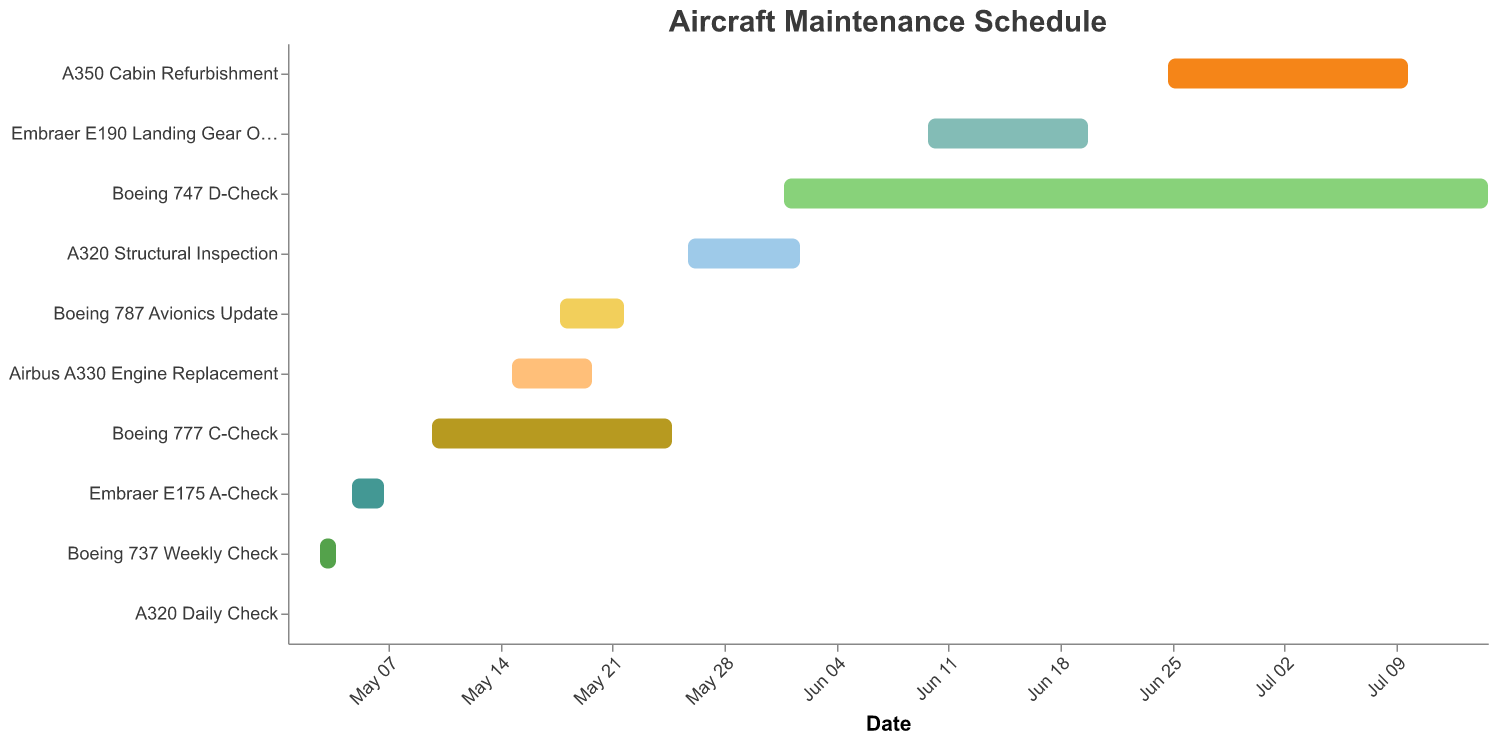What is the duration of the Boeing 777 C-Check? The Gantt chart displays the duration of each task. Look for the bar labeled "Boeing 777 C-Check" and identify the duration value indicated in the tooltip or data table.
Answer: 16 days When does the A350 Cabin Refurbishment start and end? To determine the start and end dates for the A350 Cabin Refurbishment, find the corresponding bar on the Gantt chart and refer to the tooltip or the x-axis dates.
Answer: Starts on 2023-06-25 and ends on 2023-07-10 Which maintenance task takes the longest to complete? To determine the longest task, compare the lengths of all bars in the Gantt chart. The longest horizontal bar represents the task with the longest duration.
Answer: Boeing 747 D-Check How many maintenance tasks are scheduled for May 2023? Identify all tasks with start dates within May 2023 by examining the x-axis and corresponding bars on the Gantt chart. Count all such tasks.
Answer: 6 tasks Which maintenance tasks overlap with the Boeing 787 Avionics Update? Find the bar for the Boeing 787 Avionics Update and check for any other bars that overlap with its duration from 2023-05-18 to 2023-05-22.
Answer: Airbus A330 Engine Replacement and Boeing 777 C-Check How many more days does the A320 Structural Inspection take compared to the Embraer E175 A-Check? Subtract the duration of the Embraer E175 A-Check from the duration of the A320 Structural Inspection. First find the duration of each in the tooltip.
Answer: 8 days - 3 days = 5 days Which tasks are scheduled to start in June 2023? Identify all bars on the chart that start on dates within June 2023 by referencing the x-axis and start dates mentioned in the tooltips.
Answer: Boeing 747 D-Check, Embraer E190 Landing Gear Overhaul, A350 Cabin Refurbishment What is the total combined duration of the Boeing 777 C-Check and the Airbus A330 Engine Replacement? Add the durations of both the Boeing 777 C-Check and the Airbus A330 Engine Replacement by finding each duration in the tooltip.
Answer: 16 days + 6 days = 22 days What is the shortest maintenance task on the schedule? Identify the shortest horizontal bar on the Gantt chart by comparing their lengths and checking the durations in the tooltips.
Answer: A320 Daily Check 